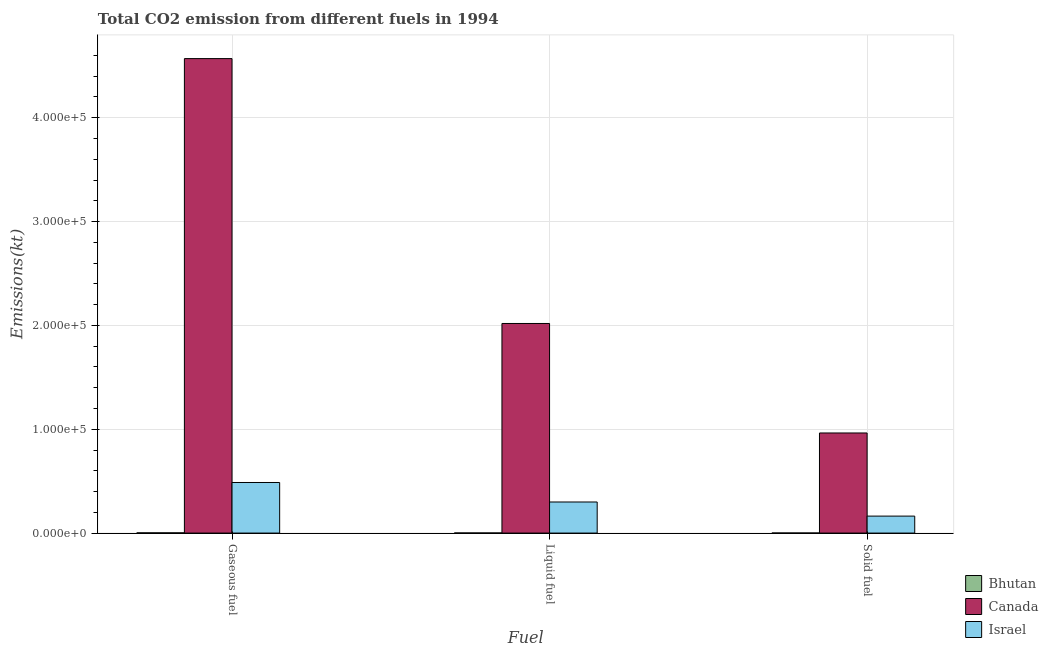How many different coloured bars are there?
Your answer should be very brief. 3. How many groups of bars are there?
Your response must be concise. 3. Are the number of bars on each tick of the X-axis equal?
Provide a short and direct response. Yes. How many bars are there on the 3rd tick from the left?
Your answer should be compact. 3. How many bars are there on the 3rd tick from the right?
Keep it short and to the point. 3. What is the label of the 3rd group of bars from the left?
Provide a short and direct response. Solid fuel. What is the amount of co2 emissions from liquid fuel in Bhutan?
Keep it short and to the point. 91.67. Across all countries, what is the maximum amount of co2 emissions from solid fuel?
Give a very brief answer. 9.64e+04. Across all countries, what is the minimum amount of co2 emissions from gaseous fuel?
Your response must be concise. 212.69. In which country was the amount of co2 emissions from liquid fuel maximum?
Your answer should be compact. Canada. In which country was the amount of co2 emissions from liquid fuel minimum?
Provide a short and direct response. Bhutan. What is the total amount of co2 emissions from liquid fuel in the graph?
Provide a succinct answer. 2.32e+05. What is the difference between the amount of co2 emissions from liquid fuel in Canada and that in Bhutan?
Ensure brevity in your answer.  2.02e+05. What is the difference between the amount of co2 emissions from solid fuel in Bhutan and the amount of co2 emissions from liquid fuel in Israel?
Give a very brief answer. -2.99e+04. What is the average amount of co2 emissions from liquid fuel per country?
Provide a short and direct response. 7.73e+04. What is the difference between the amount of co2 emissions from gaseous fuel and amount of co2 emissions from solid fuel in Canada?
Offer a terse response. 3.61e+05. In how many countries, is the amount of co2 emissions from solid fuel greater than 180000 kt?
Offer a terse response. 0. What is the ratio of the amount of co2 emissions from solid fuel in Canada to that in Bhutan?
Give a very brief answer. 1546.47. What is the difference between the highest and the second highest amount of co2 emissions from liquid fuel?
Your response must be concise. 1.72e+05. What is the difference between the highest and the lowest amount of co2 emissions from gaseous fuel?
Ensure brevity in your answer.  4.57e+05. What does the 3rd bar from the right in Solid fuel represents?
Make the answer very short. Bhutan. Is it the case that in every country, the sum of the amount of co2 emissions from gaseous fuel and amount of co2 emissions from liquid fuel is greater than the amount of co2 emissions from solid fuel?
Provide a succinct answer. Yes. How many bars are there?
Your answer should be very brief. 9. How many countries are there in the graph?
Give a very brief answer. 3. What is the difference between two consecutive major ticks on the Y-axis?
Your answer should be compact. 1.00e+05. Are the values on the major ticks of Y-axis written in scientific E-notation?
Offer a terse response. Yes. Does the graph contain any zero values?
Keep it short and to the point. No. Does the graph contain grids?
Your answer should be compact. Yes. Where does the legend appear in the graph?
Keep it short and to the point. Bottom right. How are the legend labels stacked?
Offer a very short reply. Vertical. What is the title of the graph?
Offer a very short reply. Total CO2 emission from different fuels in 1994. What is the label or title of the X-axis?
Provide a short and direct response. Fuel. What is the label or title of the Y-axis?
Offer a terse response. Emissions(kt). What is the Emissions(kt) of Bhutan in Gaseous fuel?
Give a very brief answer. 212.69. What is the Emissions(kt) in Canada in Gaseous fuel?
Ensure brevity in your answer.  4.57e+05. What is the Emissions(kt) of Israel in Gaseous fuel?
Your answer should be very brief. 4.87e+04. What is the Emissions(kt) in Bhutan in Liquid fuel?
Provide a succinct answer. 91.67. What is the Emissions(kt) in Canada in Liquid fuel?
Your answer should be compact. 2.02e+05. What is the Emissions(kt) of Israel in Liquid fuel?
Give a very brief answer. 2.99e+04. What is the Emissions(kt) in Bhutan in Solid fuel?
Your response must be concise. 62.34. What is the Emissions(kt) of Canada in Solid fuel?
Your answer should be compact. 9.64e+04. What is the Emissions(kt) of Israel in Solid fuel?
Offer a terse response. 1.63e+04. Across all Fuel, what is the maximum Emissions(kt) in Bhutan?
Your response must be concise. 212.69. Across all Fuel, what is the maximum Emissions(kt) of Canada?
Provide a succinct answer. 4.57e+05. Across all Fuel, what is the maximum Emissions(kt) of Israel?
Make the answer very short. 4.87e+04. Across all Fuel, what is the minimum Emissions(kt) of Bhutan?
Ensure brevity in your answer.  62.34. Across all Fuel, what is the minimum Emissions(kt) in Canada?
Keep it short and to the point. 9.64e+04. Across all Fuel, what is the minimum Emissions(kt) of Israel?
Your response must be concise. 1.63e+04. What is the total Emissions(kt) of Bhutan in the graph?
Make the answer very short. 366.7. What is the total Emissions(kt) of Canada in the graph?
Offer a terse response. 7.55e+05. What is the total Emissions(kt) of Israel in the graph?
Provide a short and direct response. 9.50e+04. What is the difference between the Emissions(kt) in Bhutan in Gaseous fuel and that in Liquid fuel?
Your answer should be very brief. 121.01. What is the difference between the Emissions(kt) of Canada in Gaseous fuel and that in Liquid fuel?
Offer a terse response. 2.55e+05. What is the difference between the Emissions(kt) in Israel in Gaseous fuel and that in Liquid fuel?
Provide a short and direct response. 1.88e+04. What is the difference between the Emissions(kt) in Bhutan in Gaseous fuel and that in Solid fuel?
Give a very brief answer. 150.35. What is the difference between the Emissions(kt) of Canada in Gaseous fuel and that in Solid fuel?
Ensure brevity in your answer.  3.61e+05. What is the difference between the Emissions(kt) of Israel in Gaseous fuel and that in Solid fuel?
Offer a very short reply. 3.24e+04. What is the difference between the Emissions(kt) of Bhutan in Liquid fuel and that in Solid fuel?
Your response must be concise. 29.34. What is the difference between the Emissions(kt) in Canada in Liquid fuel and that in Solid fuel?
Provide a short and direct response. 1.05e+05. What is the difference between the Emissions(kt) in Israel in Liquid fuel and that in Solid fuel?
Provide a short and direct response. 1.36e+04. What is the difference between the Emissions(kt) of Bhutan in Gaseous fuel and the Emissions(kt) of Canada in Liquid fuel?
Your answer should be compact. -2.02e+05. What is the difference between the Emissions(kt) in Bhutan in Gaseous fuel and the Emissions(kt) in Israel in Liquid fuel?
Keep it short and to the point. -2.97e+04. What is the difference between the Emissions(kt) of Canada in Gaseous fuel and the Emissions(kt) of Israel in Liquid fuel?
Your answer should be compact. 4.27e+05. What is the difference between the Emissions(kt) of Bhutan in Gaseous fuel and the Emissions(kt) of Canada in Solid fuel?
Your answer should be very brief. -9.62e+04. What is the difference between the Emissions(kt) in Bhutan in Gaseous fuel and the Emissions(kt) in Israel in Solid fuel?
Your answer should be compact. -1.61e+04. What is the difference between the Emissions(kt) of Canada in Gaseous fuel and the Emissions(kt) of Israel in Solid fuel?
Your answer should be compact. 4.41e+05. What is the difference between the Emissions(kt) of Bhutan in Liquid fuel and the Emissions(kt) of Canada in Solid fuel?
Ensure brevity in your answer.  -9.63e+04. What is the difference between the Emissions(kt) in Bhutan in Liquid fuel and the Emissions(kt) in Israel in Solid fuel?
Your answer should be very brief. -1.62e+04. What is the difference between the Emissions(kt) of Canada in Liquid fuel and the Emissions(kt) of Israel in Solid fuel?
Give a very brief answer. 1.86e+05. What is the average Emissions(kt) in Bhutan per Fuel?
Your answer should be compact. 122.23. What is the average Emissions(kt) of Canada per Fuel?
Provide a short and direct response. 2.52e+05. What is the average Emissions(kt) in Israel per Fuel?
Your answer should be very brief. 3.17e+04. What is the difference between the Emissions(kt) of Bhutan and Emissions(kt) of Canada in Gaseous fuel?
Provide a succinct answer. -4.57e+05. What is the difference between the Emissions(kt) of Bhutan and Emissions(kt) of Israel in Gaseous fuel?
Ensure brevity in your answer.  -4.85e+04. What is the difference between the Emissions(kt) in Canada and Emissions(kt) in Israel in Gaseous fuel?
Give a very brief answer. 4.08e+05. What is the difference between the Emissions(kt) in Bhutan and Emissions(kt) in Canada in Liquid fuel?
Keep it short and to the point. -2.02e+05. What is the difference between the Emissions(kt) in Bhutan and Emissions(kt) in Israel in Liquid fuel?
Your answer should be compact. -2.98e+04. What is the difference between the Emissions(kt) of Canada and Emissions(kt) of Israel in Liquid fuel?
Offer a terse response. 1.72e+05. What is the difference between the Emissions(kt) in Bhutan and Emissions(kt) in Canada in Solid fuel?
Your answer should be compact. -9.63e+04. What is the difference between the Emissions(kt) of Bhutan and Emissions(kt) of Israel in Solid fuel?
Ensure brevity in your answer.  -1.63e+04. What is the difference between the Emissions(kt) in Canada and Emissions(kt) in Israel in Solid fuel?
Your response must be concise. 8.01e+04. What is the ratio of the Emissions(kt) of Bhutan in Gaseous fuel to that in Liquid fuel?
Offer a very short reply. 2.32. What is the ratio of the Emissions(kt) of Canada in Gaseous fuel to that in Liquid fuel?
Your answer should be compact. 2.26. What is the ratio of the Emissions(kt) in Israel in Gaseous fuel to that in Liquid fuel?
Provide a succinct answer. 1.63. What is the ratio of the Emissions(kt) in Bhutan in Gaseous fuel to that in Solid fuel?
Make the answer very short. 3.41. What is the ratio of the Emissions(kt) of Canada in Gaseous fuel to that in Solid fuel?
Provide a succinct answer. 4.74. What is the ratio of the Emissions(kt) in Israel in Gaseous fuel to that in Solid fuel?
Keep it short and to the point. 2.98. What is the ratio of the Emissions(kt) in Bhutan in Liquid fuel to that in Solid fuel?
Your response must be concise. 1.47. What is the ratio of the Emissions(kt) in Canada in Liquid fuel to that in Solid fuel?
Keep it short and to the point. 2.09. What is the ratio of the Emissions(kt) in Israel in Liquid fuel to that in Solid fuel?
Offer a very short reply. 1.83. What is the difference between the highest and the second highest Emissions(kt) in Bhutan?
Your response must be concise. 121.01. What is the difference between the highest and the second highest Emissions(kt) in Canada?
Make the answer very short. 2.55e+05. What is the difference between the highest and the second highest Emissions(kt) of Israel?
Give a very brief answer. 1.88e+04. What is the difference between the highest and the lowest Emissions(kt) of Bhutan?
Make the answer very short. 150.35. What is the difference between the highest and the lowest Emissions(kt) of Canada?
Offer a very short reply. 3.61e+05. What is the difference between the highest and the lowest Emissions(kt) of Israel?
Provide a short and direct response. 3.24e+04. 